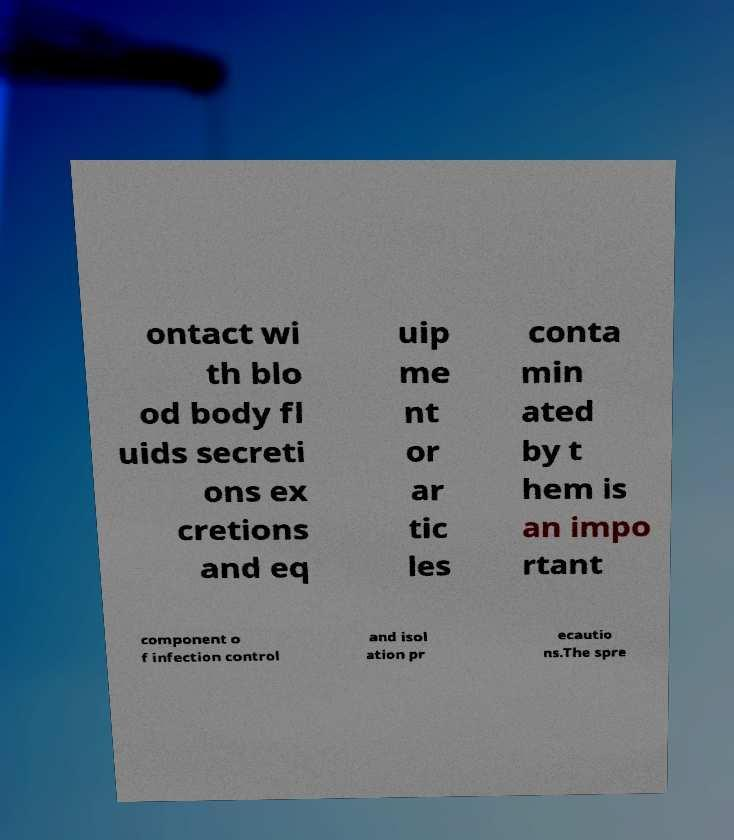For documentation purposes, I need the text within this image transcribed. Could you provide that? ontact wi th blo od body fl uids secreti ons ex cretions and eq uip me nt or ar tic les conta min ated by t hem is an impo rtant component o f infection control and isol ation pr ecautio ns.The spre 